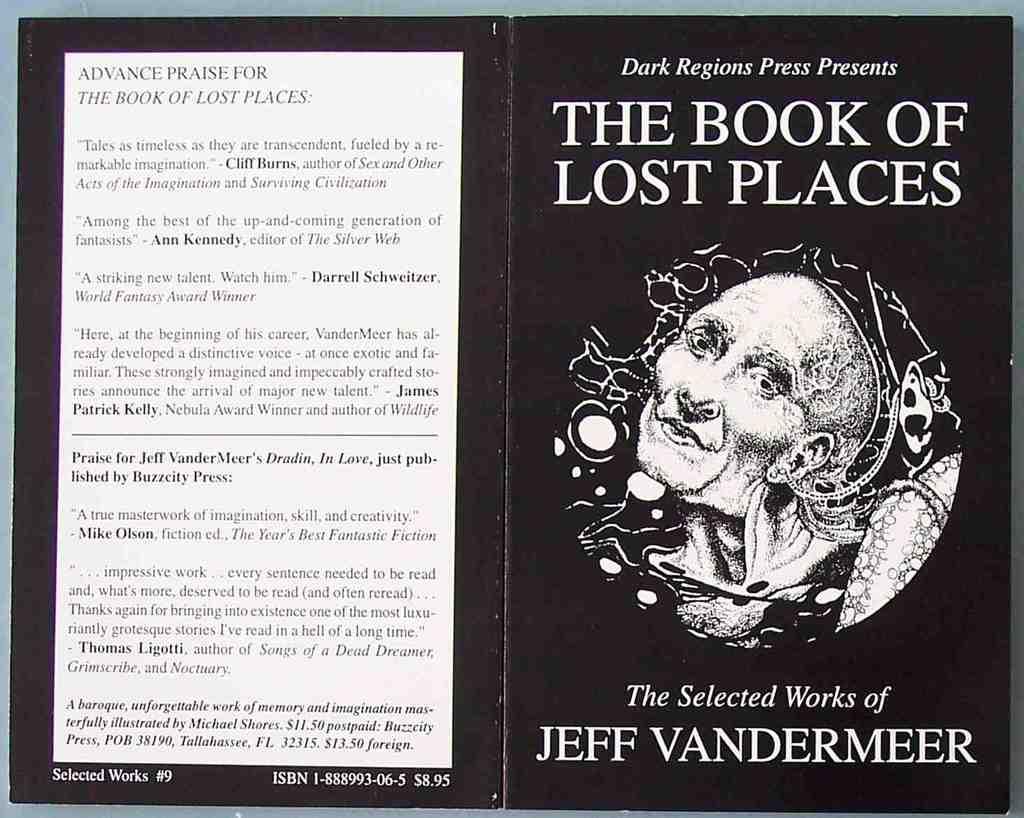Who wrote this book?
Your response must be concise. Jeff vandermeer. Is that a taxi?
Keep it short and to the point. No. 